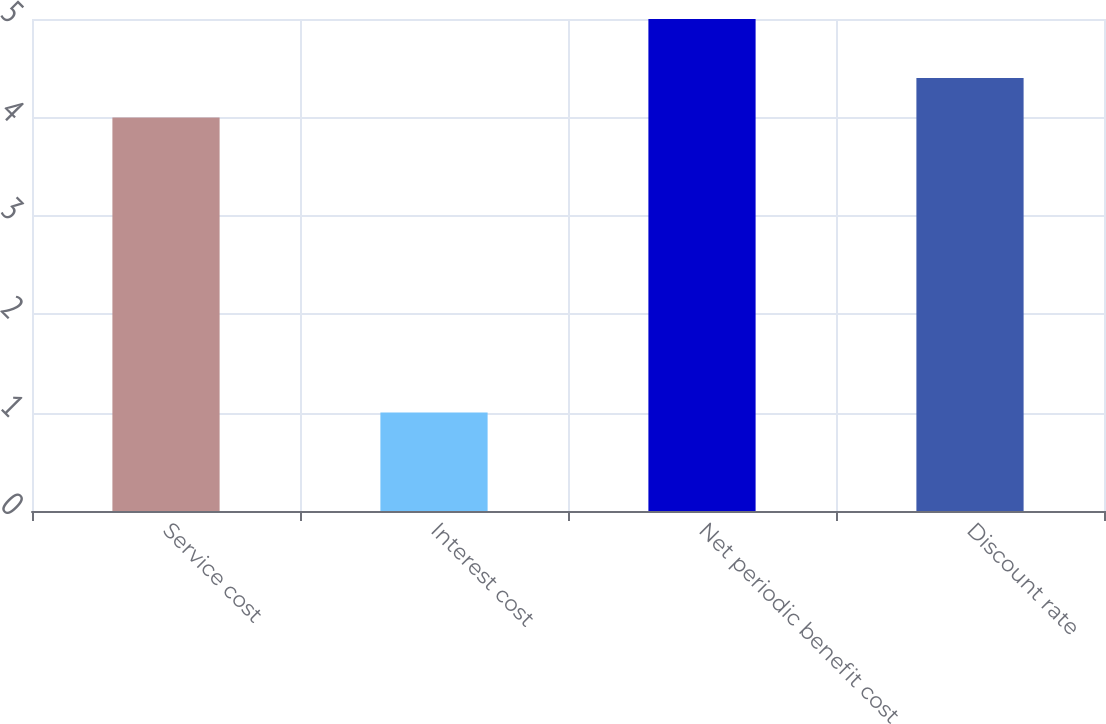Convert chart to OTSL. <chart><loc_0><loc_0><loc_500><loc_500><bar_chart><fcel>Service cost<fcel>Interest cost<fcel>Net periodic benefit cost<fcel>Discount rate<nl><fcel>4<fcel>1<fcel>5<fcel>4.4<nl></chart> 